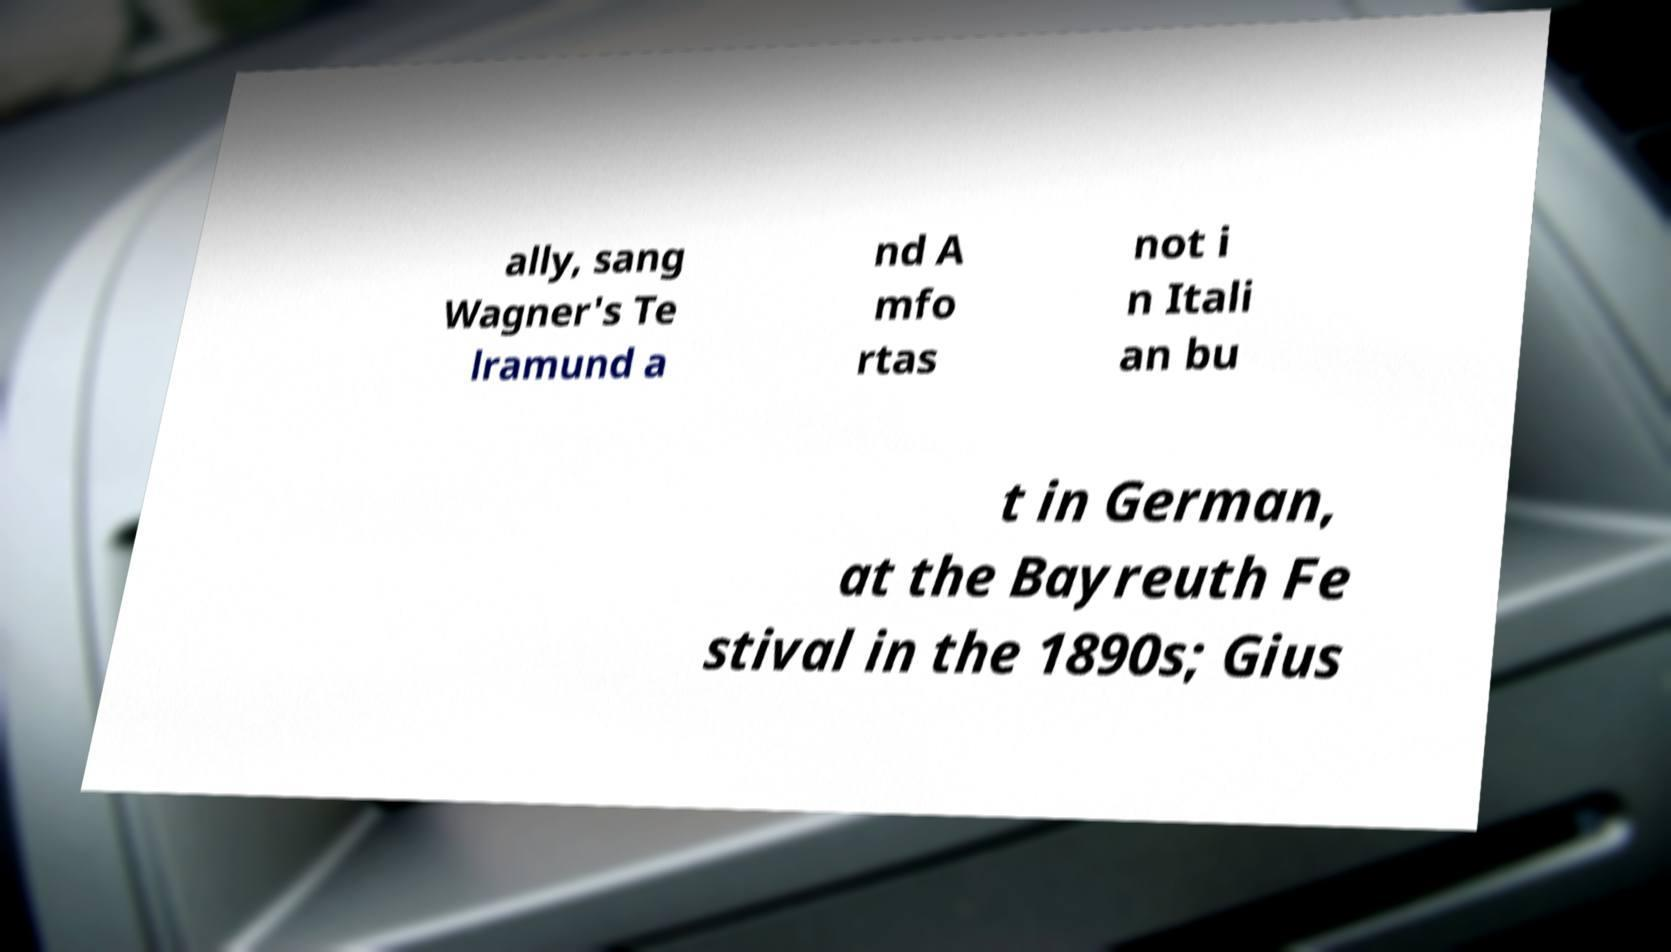What messages or text are displayed in this image? I need them in a readable, typed format. ally, sang Wagner's Te lramund a nd A mfo rtas not i n Itali an bu t in German, at the Bayreuth Fe stival in the 1890s; Gius 